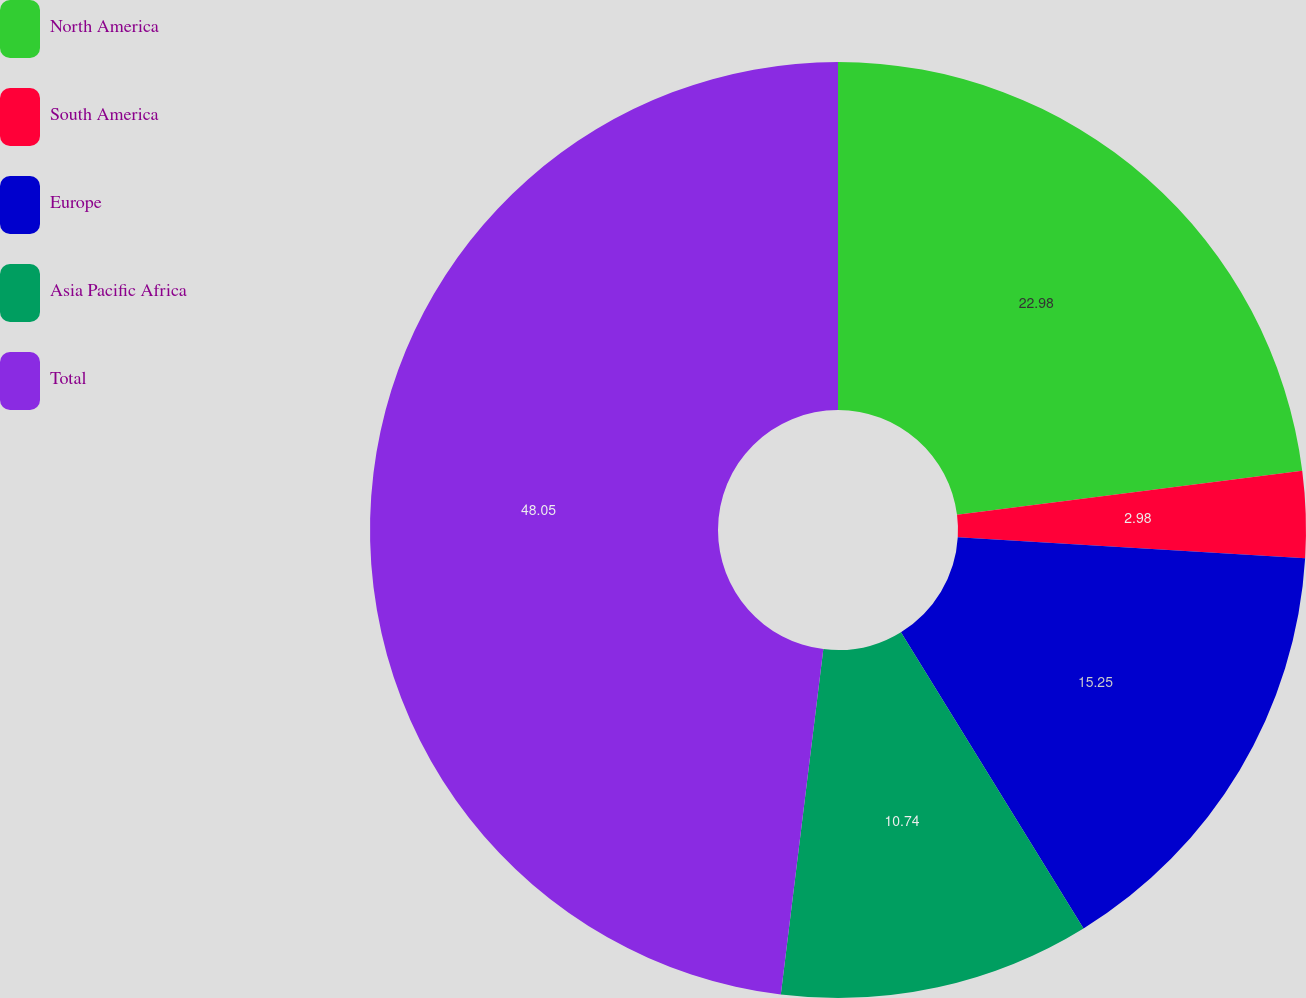Convert chart. <chart><loc_0><loc_0><loc_500><loc_500><pie_chart><fcel>North America<fcel>South America<fcel>Europe<fcel>Asia Pacific Africa<fcel>Total<nl><fcel>22.98%<fcel>2.98%<fcel>15.25%<fcel>10.74%<fcel>48.05%<nl></chart> 